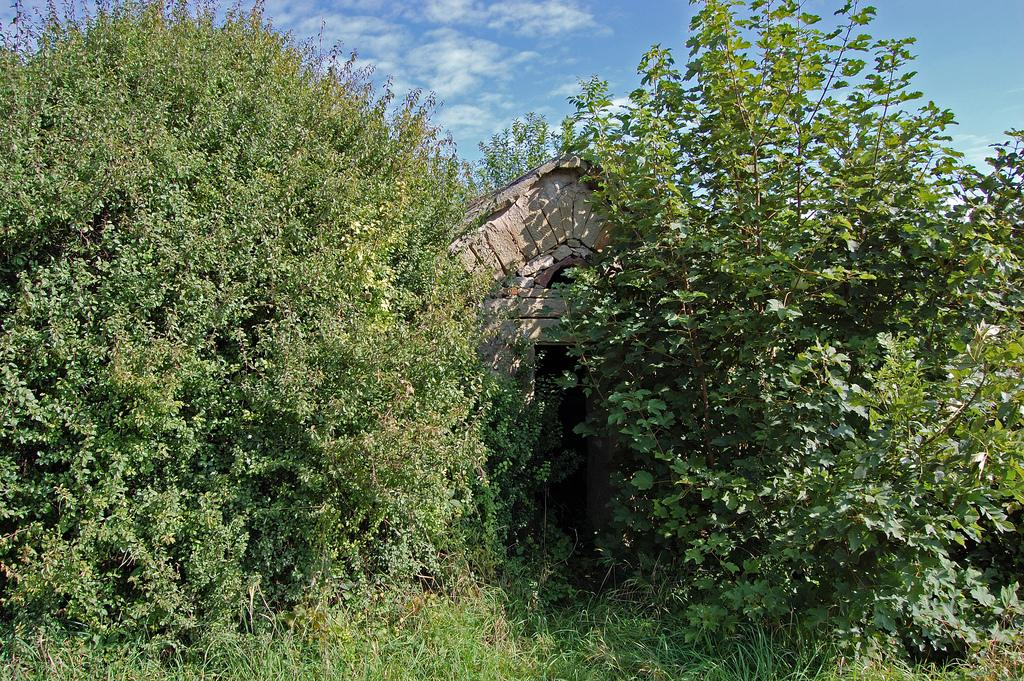What type of structure is present in the image? There is a house in the image. What type of vegetation can be seen in the image? There are trees and plants in the image. What part of the natural environment is visible in the image? The sky is visible in the background of the image. How many dimes are scattered among the plants in the image? There are no dimes present in the image; it features a house, trees, plants, and the sky. Can you see any ears on the trees in the image? Trees do not have ears, so this detail cannot be found in the image. 